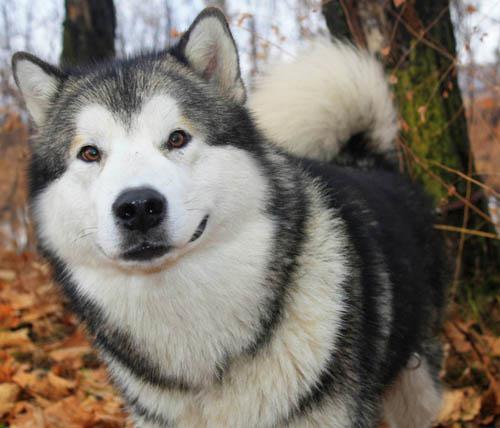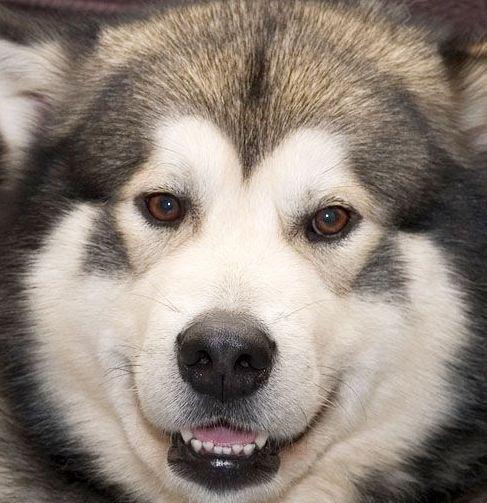The first image is the image on the left, the second image is the image on the right. Examine the images to the left and right. Is the description "Each image includes a black-and-white husky with an open mouth, and at least one image includes a dog reclining on its belly with its front paws extended." accurate? Answer yes or no. No. 